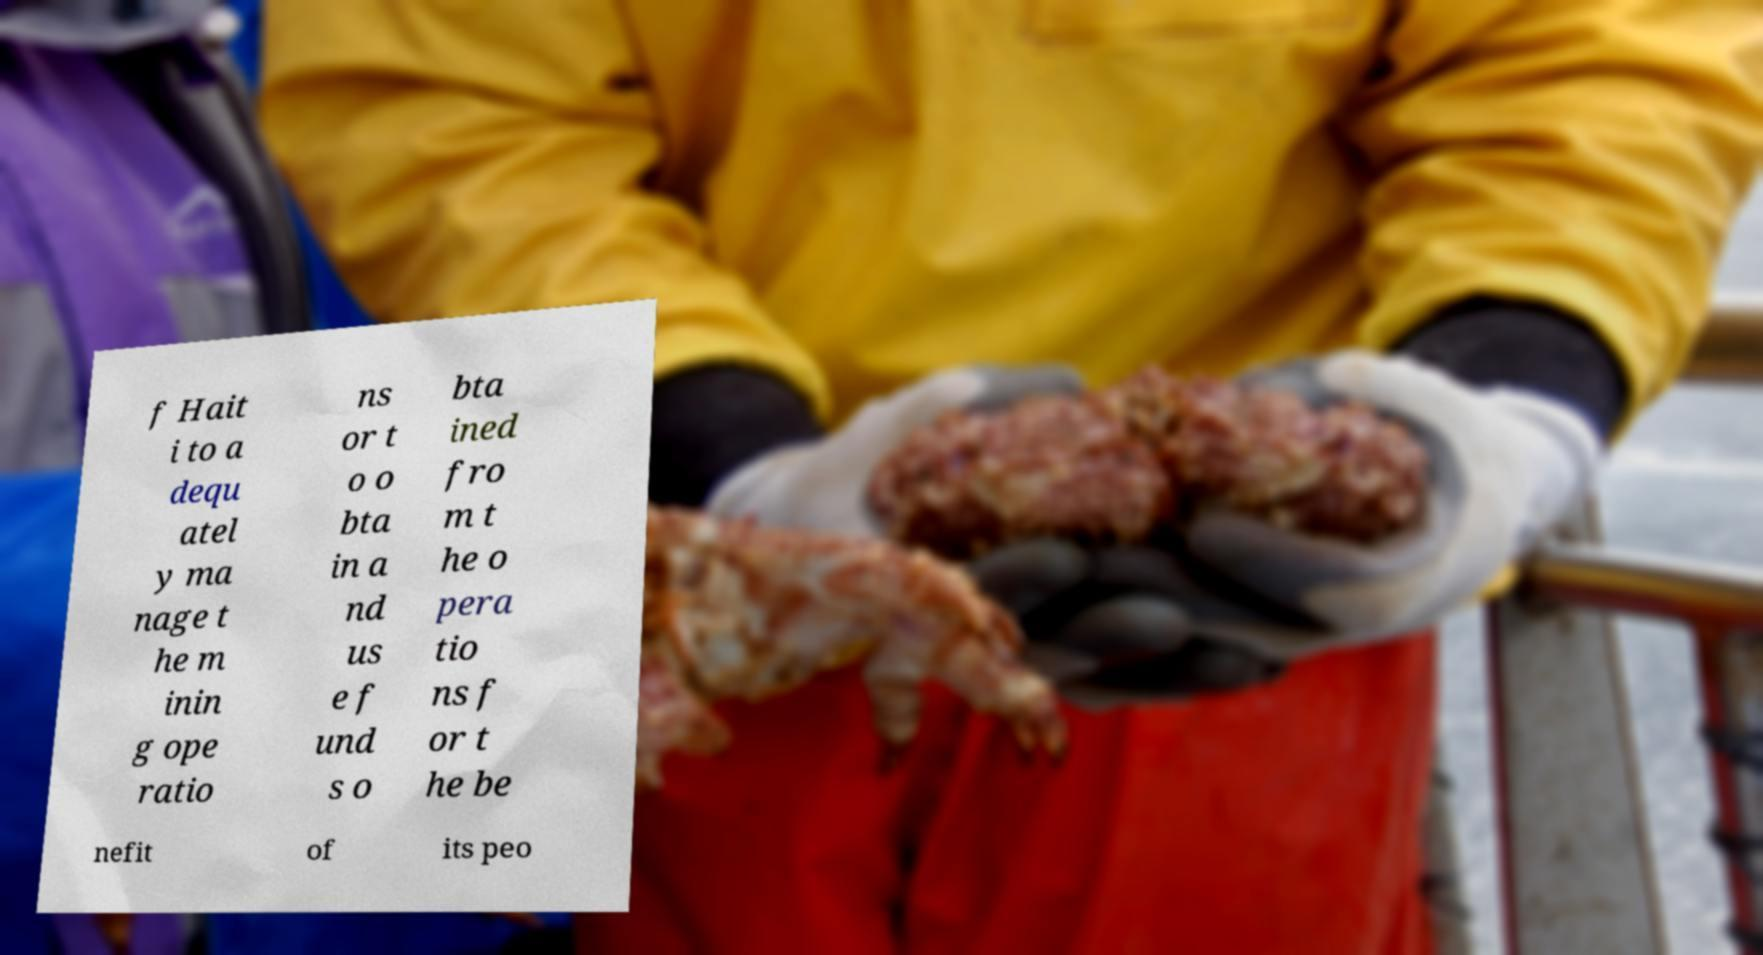Could you extract and type out the text from this image? f Hait i to a dequ atel y ma nage t he m inin g ope ratio ns or t o o bta in a nd us e f und s o bta ined fro m t he o pera tio ns f or t he be nefit of its peo 